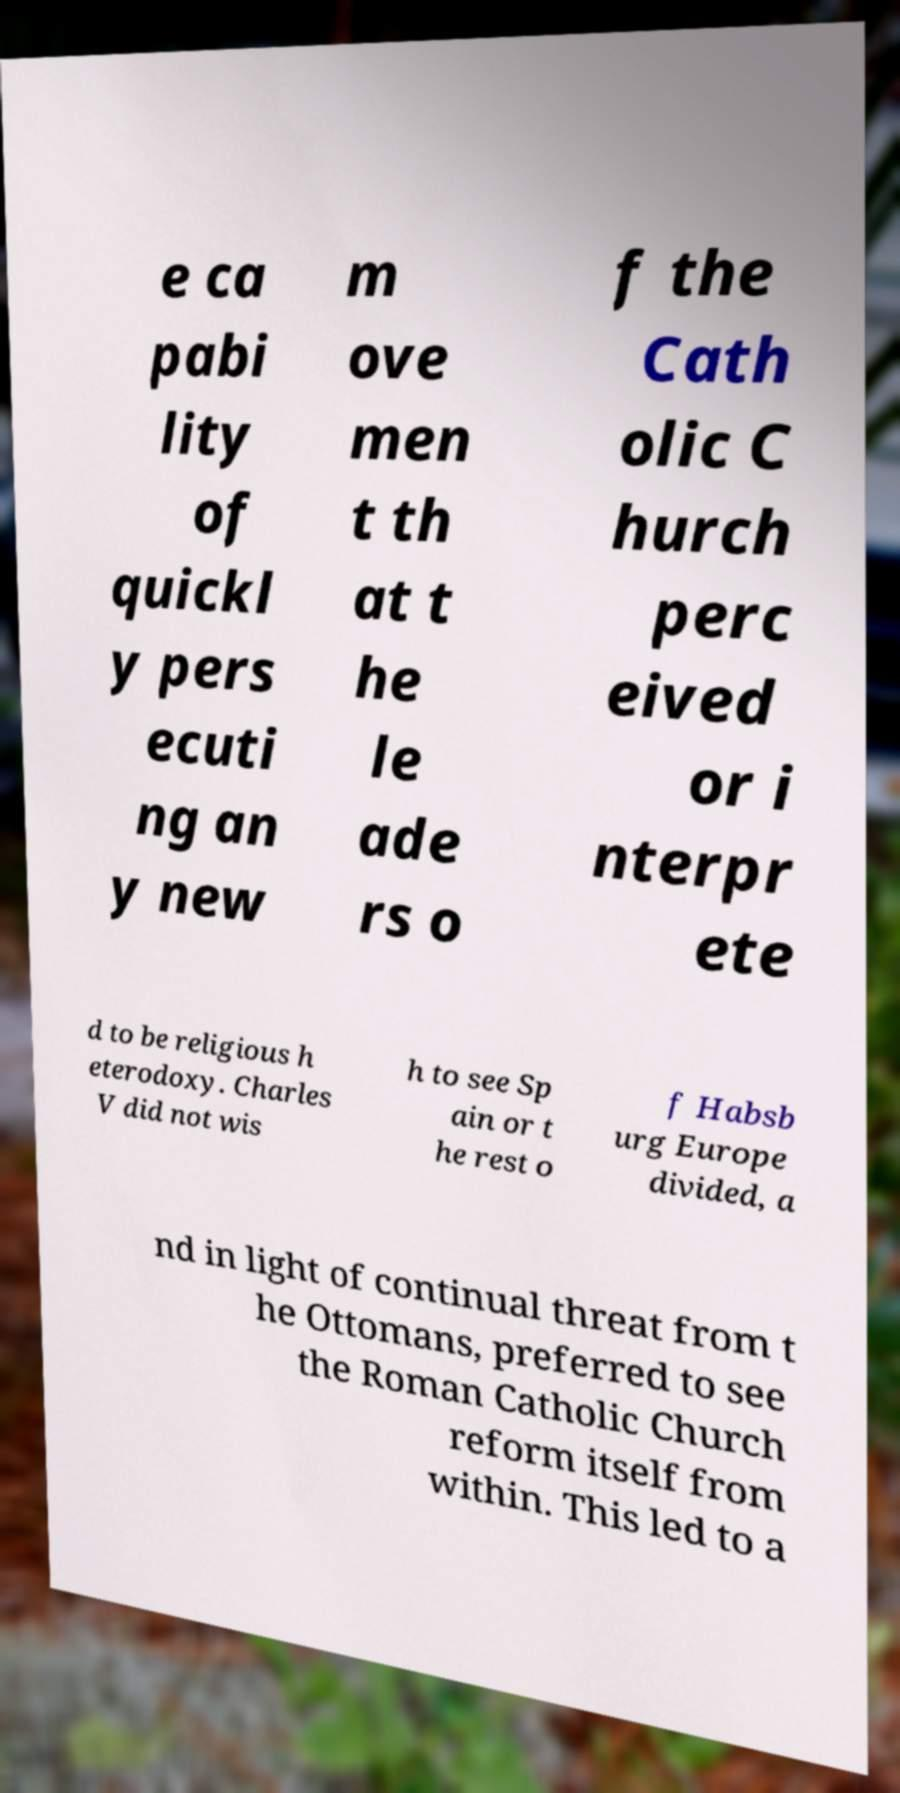Please read and relay the text visible in this image. What does it say? e ca pabi lity of quickl y pers ecuti ng an y new m ove men t th at t he le ade rs o f the Cath olic C hurch perc eived or i nterpr ete d to be religious h eterodoxy. Charles V did not wis h to see Sp ain or t he rest o f Habsb urg Europe divided, a nd in light of continual threat from t he Ottomans, preferred to see the Roman Catholic Church reform itself from within. This led to a 